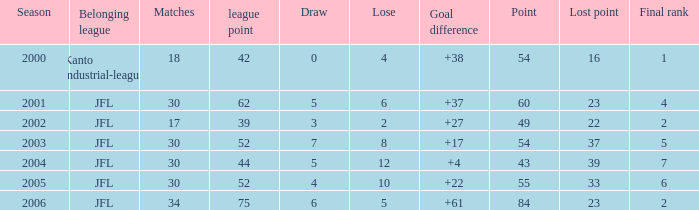Inform me of the top matches for point 43 and ending rank below None. 